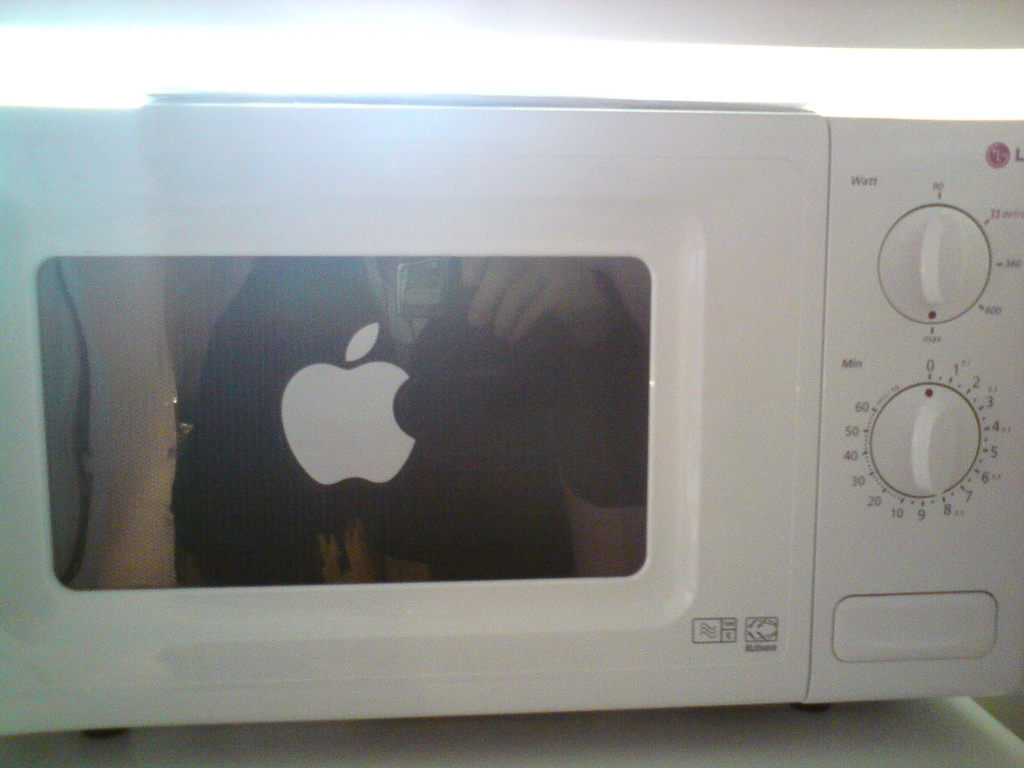Provide a one-sentence caption for the provided image.
Reference OCR token: Watt, NEK A white microwave oven with an Apple logo sticker on the door. 